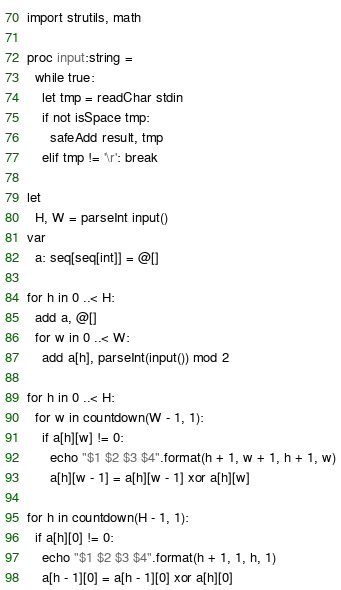<code> <loc_0><loc_0><loc_500><loc_500><_Nim_>import strutils, math

proc input:string =
  while true:
    let tmp = readChar stdin
    if not isSpace tmp:
      safeAdd result, tmp
    elif tmp != '\r': break

let
  H, W = parseInt input()
var
  a: seq[seq[int]] = @[]

for h in 0 ..< H:
  add a, @[]
  for w in 0 ..< W:
    add a[h], parseInt(input()) mod 2

for h in 0 ..< H:
  for w in countdown(W - 1, 1):
    if a[h][w] != 0:
      echo "$1 $2 $3 $4".format(h + 1, w + 1, h + 1, w)
      a[h][w - 1] = a[h][w - 1] xor a[h][w]

for h in countdown(H - 1, 1):
  if a[h][0] != 0:
    echo "$1 $2 $3 $4".format(h + 1, 1, h, 1)
    a[h - 1][0] = a[h - 1][0] xor a[h][0]
</code> 